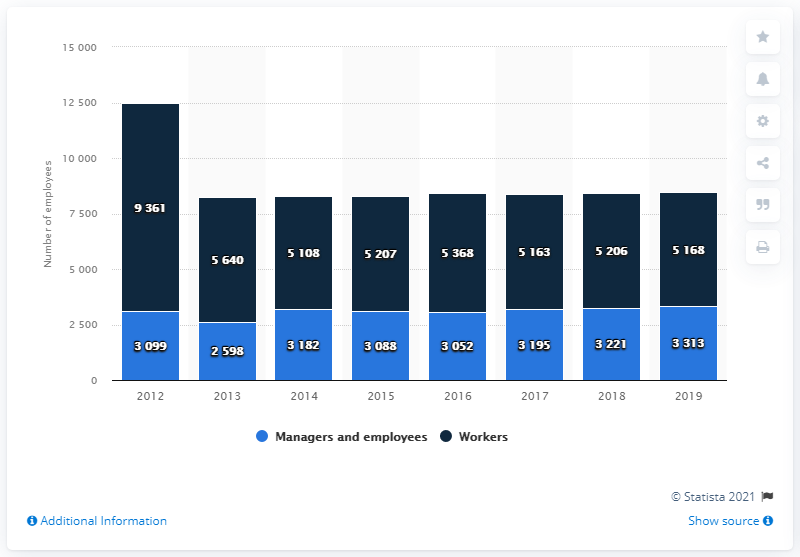Highlight a few significant elements in this photo. Between 2012 and 2013, there were approximately 9,361 blue-collar workers. As of 2019, the Barilla Group employed 5,168 blue-collar workers. In 2019, a total of 3,313 managers and employees were working for the Barilla Group. 